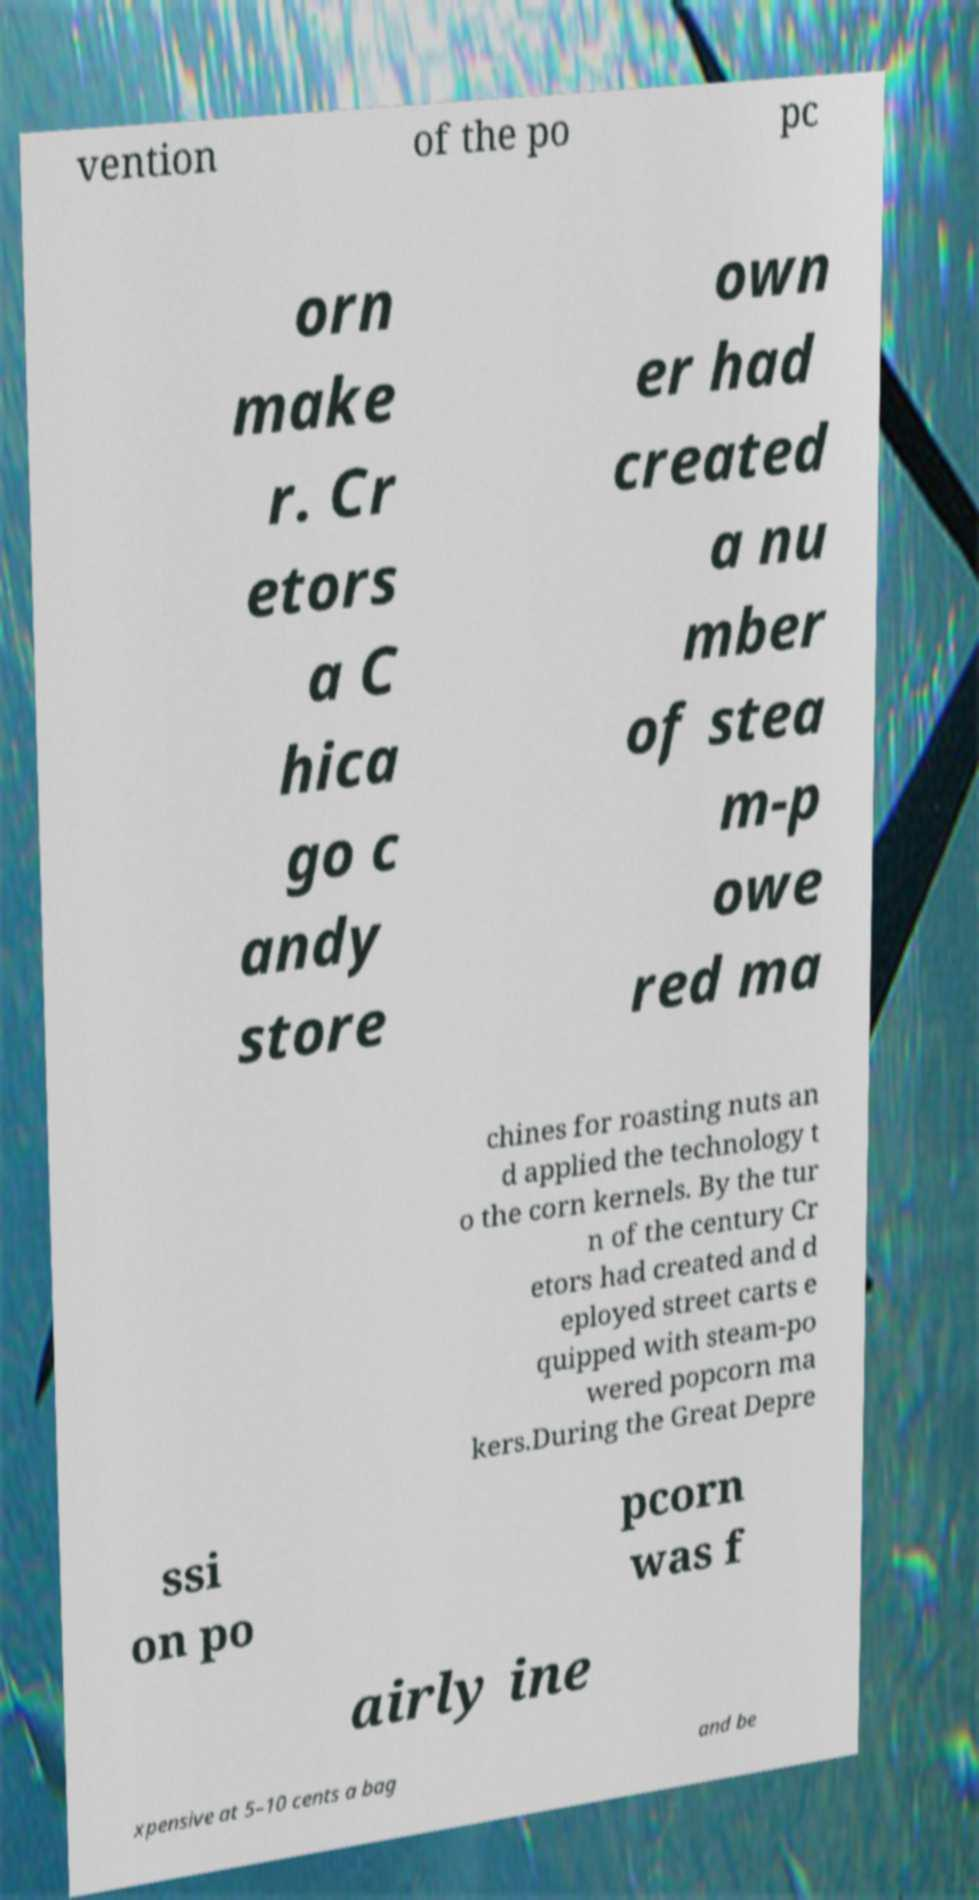Can you read and provide the text displayed in the image?This photo seems to have some interesting text. Can you extract and type it out for me? vention of the po pc orn make r. Cr etors a C hica go c andy store own er had created a nu mber of stea m-p owe red ma chines for roasting nuts an d applied the technology t o the corn kernels. By the tur n of the century Cr etors had created and d eployed street carts e quipped with steam-po wered popcorn ma kers.During the Great Depre ssi on po pcorn was f airly ine xpensive at 5–10 cents a bag and be 